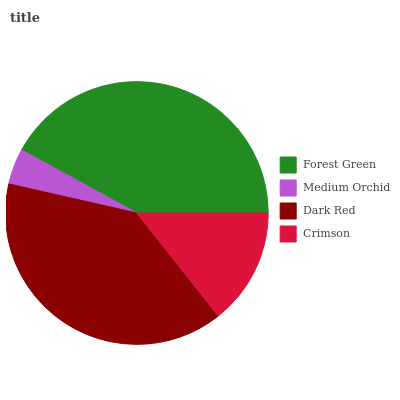Is Medium Orchid the minimum?
Answer yes or no. Yes. Is Forest Green the maximum?
Answer yes or no. Yes. Is Dark Red the minimum?
Answer yes or no. No. Is Dark Red the maximum?
Answer yes or no. No. Is Dark Red greater than Medium Orchid?
Answer yes or no. Yes. Is Medium Orchid less than Dark Red?
Answer yes or no. Yes. Is Medium Orchid greater than Dark Red?
Answer yes or no. No. Is Dark Red less than Medium Orchid?
Answer yes or no. No. Is Dark Red the high median?
Answer yes or no. Yes. Is Crimson the low median?
Answer yes or no. Yes. Is Forest Green the high median?
Answer yes or no. No. Is Medium Orchid the low median?
Answer yes or no. No. 